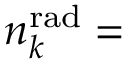Convert formula to latex. <formula><loc_0><loc_0><loc_500><loc_500>n _ { k } ^ { r a d } =</formula> 